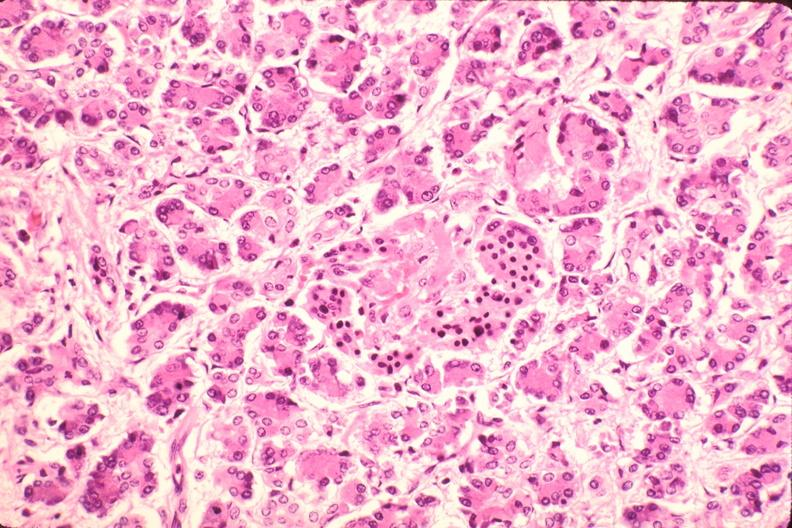does this image show pancreas, microthrombi, thrombotic thrombocytopenic purpura?
Answer the question using a single word or phrase. Yes 